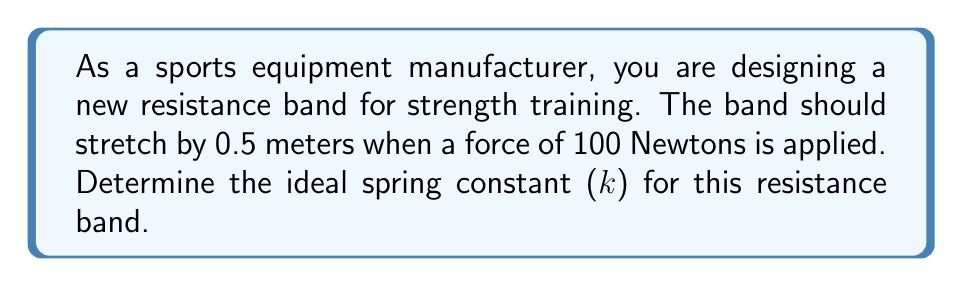Provide a solution to this math problem. To solve this problem, we'll use Hooke's Law, which describes the relationship between the force applied to a spring (or in this case, a resistance band) and its displacement from equilibrium. The formula is:

$$F = kx$$

Where:
$F$ = Force applied (in Newtons)
$k$ = Spring constant (in N/m)
$x$ = Displacement (in meters)

Given:
$F = 100$ N
$x = 0.5$ m

We need to solve for $k$. Rearranging the equation:

$$k = \frac{F}{x}$$

Substituting the known values:

$$k = \frac{100 \text{ N}}{0.5 \text{ m}}$$

$$k = 200 \text{ N/m}$$

Therefore, the ideal spring constant for the resistance band is 200 N/m.

This means that for every meter the band is stretched, it will provide 200 Newtons of resistance force. This spring constant ensures that when the band is stretched by 0.5 meters, it will provide the desired 100 Newtons of force for effective strength training.
Answer: $k = 200 \text{ N/m}$ 